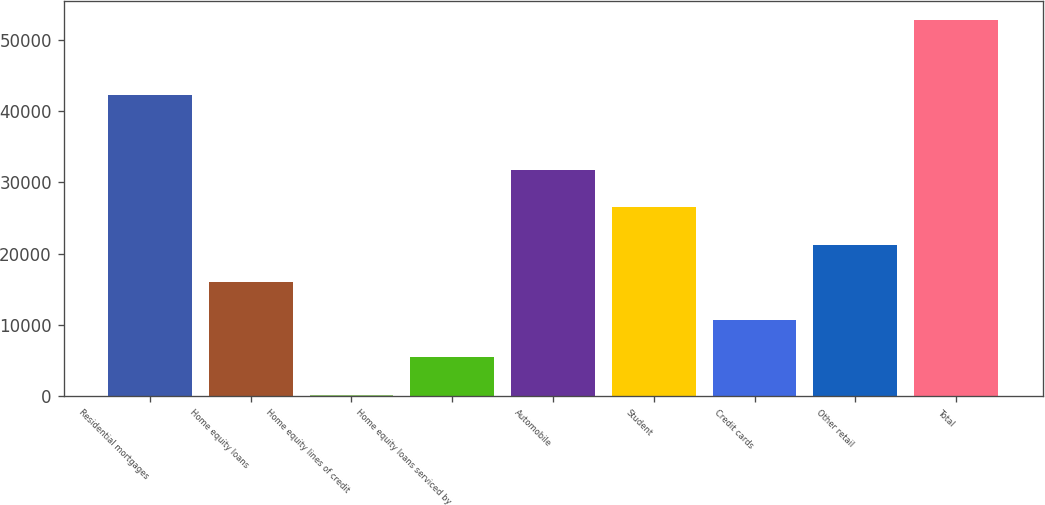<chart> <loc_0><loc_0><loc_500><loc_500><bar_chart><fcel>Residential mortgages<fcel>Home equity loans<fcel>Home equity lines of credit<fcel>Home equity loans serviced by<fcel>Automobile<fcel>Student<fcel>Credit cards<fcel>Other retail<fcel>Total<nl><fcel>42330<fcel>15972.5<fcel>158<fcel>5429.5<fcel>31787<fcel>26515.5<fcel>10701<fcel>21244<fcel>52873<nl></chart> 